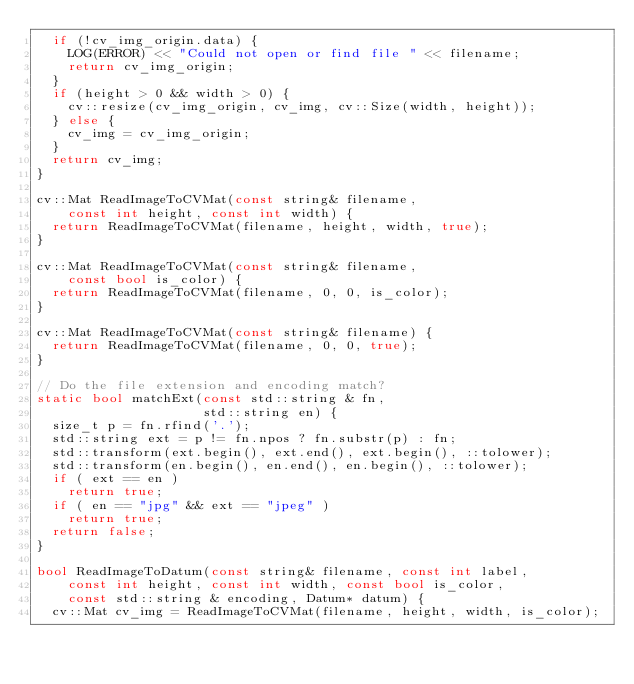<code> <loc_0><loc_0><loc_500><loc_500><_C++_>  if (!cv_img_origin.data) {
    LOG(ERROR) << "Could not open or find file " << filename;
    return cv_img_origin;
  }
  if (height > 0 && width > 0) {
    cv::resize(cv_img_origin, cv_img, cv::Size(width, height));
  } else {
    cv_img = cv_img_origin;
  }
  return cv_img;
}

cv::Mat ReadImageToCVMat(const string& filename,
    const int height, const int width) {
  return ReadImageToCVMat(filename, height, width, true);
}

cv::Mat ReadImageToCVMat(const string& filename,
    const bool is_color) {
  return ReadImageToCVMat(filename, 0, 0, is_color);
}

cv::Mat ReadImageToCVMat(const string& filename) {
  return ReadImageToCVMat(filename, 0, 0, true);
}

// Do the file extension and encoding match?
static bool matchExt(const std::string & fn,
                     std::string en) {
  size_t p = fn.rfind('.');
  std::string ext = p != fn.npos ? fn.substr(p) : fn;
  std::transform(ext.begin(), ext.end(), ext.begin(), ::tolower);
  std::transform(en.begin(), en.end(), en.begin(), ::tolower);
  if ( ext == en )
    return true;
  if ( en == "jpg" && ext == "jpeg" )
    return true;
  return false;
}

bool ReadImageToDatum(const string& filename, const int label,
    const int height, const int width, const bool is_color,
    const std::string & encoding, Datum* datum) {
  cv::Mat cv_img = ReadImageToCVMat(filename, height, width, is_color);</code> 